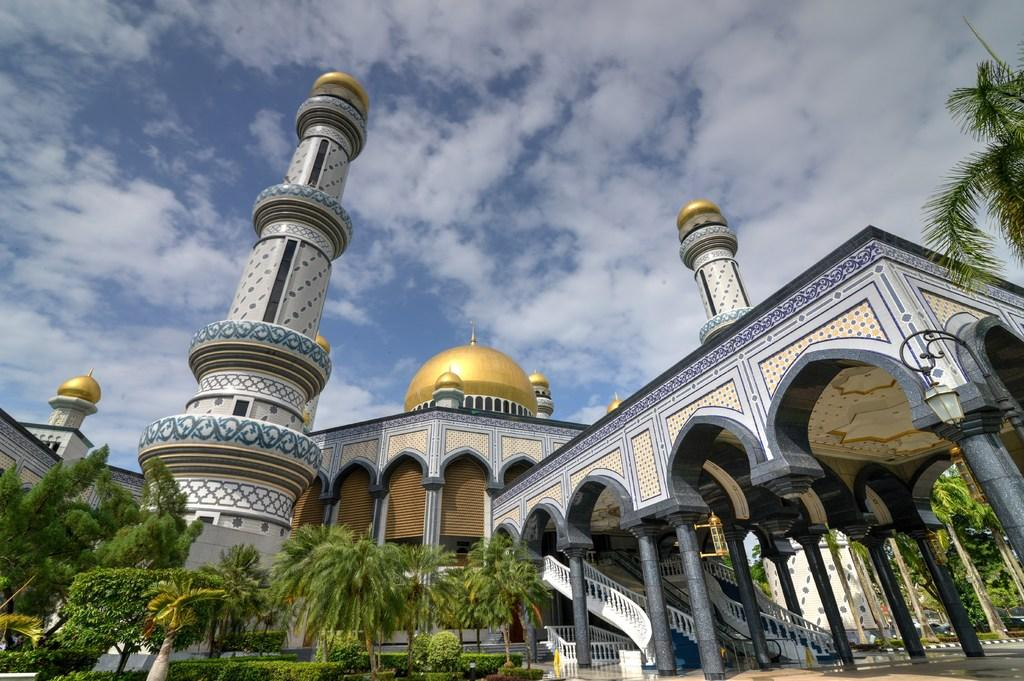How many pillars can be seen in the image? There are two pillars in the image. What is the color of the dome on the building? The dome on the building is gold-colored. What type of vegetation is present in the image? There are trees in the image. What can be seen in the background of the image? The sky is visible in the background of the image. What is the weather like in the image? The presence of clouds in the sky suggests that it is partly cloudy. What type of sweater is the servant wearing in the image? There is no servant or sweater present in the image. What is the position of the sun in the image? The sun is not visible in the image; only clouds are present in the sky. 